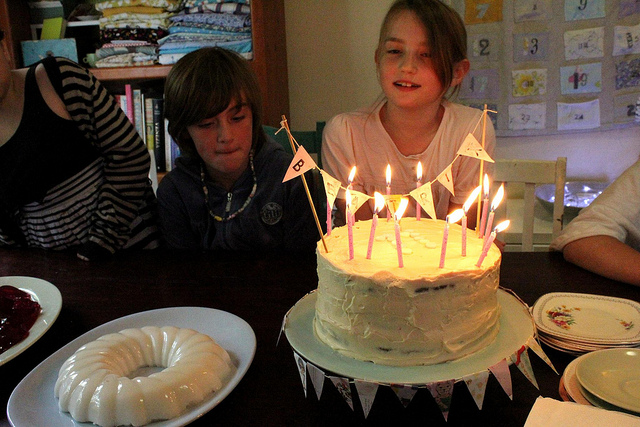What might be the occasion, judging from the image? Based on the cake, candles, and the presence of what appears to be family or friends, it seems likely that the image captures someone's birthday celebration. What is the expression of the person closest to the cake? The individual closest to the cake, presumably the celebrant, has a look of contentment and anticipation, typical for someone who is about to blow out birthday candles. 